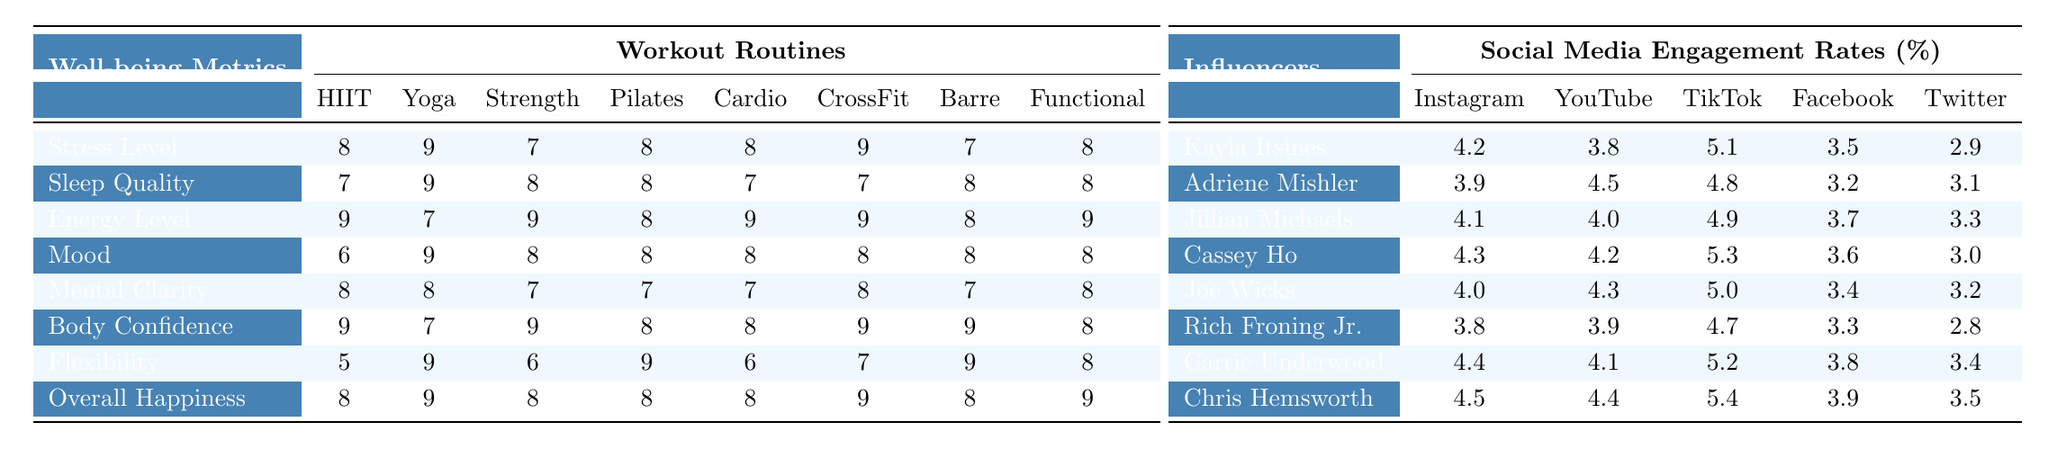What workout routine has the highest impact on overall happiness? By examining the "Overall Happiness" row in the well-being metrics section, we can see that both Yoga and CrossFit have a score of 9, which is the highest value compared to the other routines.
Answer: Yoga and CrossFit Which workout routine is least effective for improving flexibility? Looking at the "Flexibility" row, the score for HIIT is the lowest at 5, indicating it's the least effective for improving flexibility compared to others.
Answer: HIIT What is the average impact score for Strength Training across all well-being metrics? We sum the impact scores for Strength Training: (7 + 8 + 9 + 8 + 7 + 9 + 6 + 8) = 62. There are 8 metrics, so the average is 62/8 = 7.75.
Answer: 7.75 Is there any workout routine that scores the same for both Stress Level and Mood? Checking the "Stress Level" and "Mood" rows, we find that Pilates scores 8 in both categories, indicating it is the only routine that has the same score for both metrics.
Answer: Yes What is the difference in scores for Energy Level between HIIT and Pilates? The scores for HIIT and Pilates in Energy Level are 9 and 8, respectively. Therefore, the difference is 9 - 8 = 1.
Answer: 1 Which influencer received the highest engagement rate on TikTok? By reviewing the TikTok column, Chris Hemsworth has the highest engagement rate at 5.4%.
Answer: Chris Hemsworth Can you find a workout routine that improves stress, sleep, and mood equally? Analyzing the rows for Stress Level, Sleep Quality, and Mood, Pilates scores 8 for stress, 8 for sleep, and 8 for mood, thereby improving all three metrics equally.
Answer: Yes, Pilates What is the average engagement rate for Joe Wicks across all social media platforms? The engagement rates for Joe Wicks are 4.0, 4.3, 5.0, 3.4, and 3.2, which sum up to 20.9. Dividing this by 5 gives us an average of 20.9/5 = 4.18.
Answer: 4.18 Do any workout routines score above 8 in both Energy Level and Overall Happiness? Comparing the scores, CrossFit has an Energy Level score of 9 and an Overall Happiness score of 9, meaning it meets the criteria.
Answer: Yes, CrossFit Which well-being metric shows the maximum score fluctuation among the workout routines? The scores for Flexibility range from HIIT at 5 to Barre at 9, thus calculating the fluctuation gives us 9 - 5 = 4. This indicates it's the largest range among the metrics.
Answer: 4 